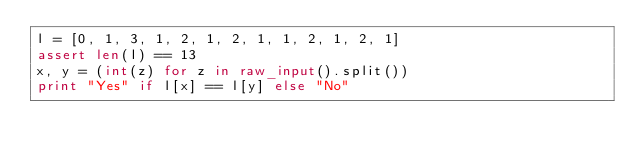Convert code to text. <code><loc_0><loc_0><loc_500><loc_500><_Python_>l = [0, 1, 3, 1, 2, 1, 2, 1, 1, 2, 1, 2, 1]
assert len(l) == 13
x, y = (int(z) for z in raw_input().split())
print "Yes" if l[x] == l[y] else "No"</code> 